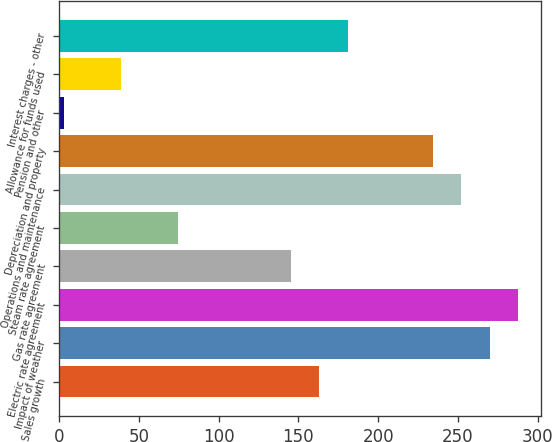Convert chart to OTSL. <chart><loc_0><loc_0><loc_500><loc_500><bar_chart><fcel>Sales growth<fcel>Impact of weather<fcel>Electric rate agreement<fcel>Gas rate agreement<fcel>Steam rate agreement<fcel>Operations and maintenance<fcel>Depreciation and property<fcel>Pension and other<fcel>Allowance for funds used<fcel>Interest charges - other<nl><fcel>163.2<fcel>270<fcel>287.8<fcel>145.4<fcel>74.2<fcel>252.2<fcel>234.4<fcel>3<fcel>38.6<fcel>181<nl></chart> 